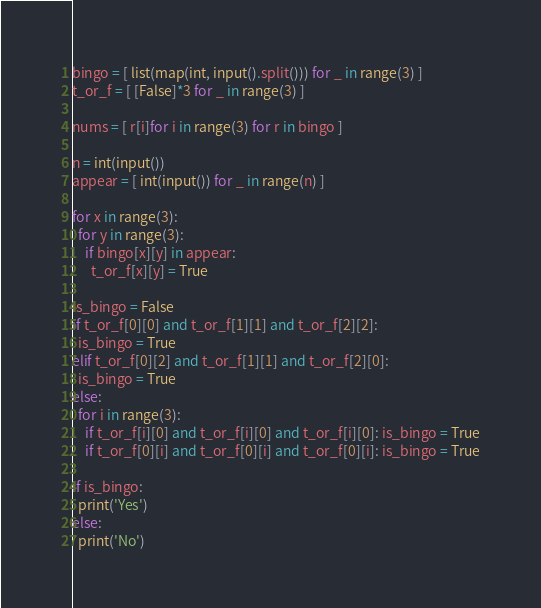<code> <loc_0><loc_0><loc_500><loc_500><_Python_>bingo = [ list(map(int, input().split())) for _ in range(3) ]
t_or_f = [ [False]*3 for _ in range(3) ]

nums = [ r[i]for i in range(3) for r in bingo ]

n = int(input())
appear = [ int(input()) for _ in range(n) ]

for x in range(3):
  for y in range(3):
    if bingo[x][y] in appear:
      t_or_f[x][y] = True

is_bingo = False
if t_or_f[0][0] and t_or_f[1][1] and t_or_f[2][2]:
  is_bingo = True
elif t_or_f[0][2] and t_or_f[1][1] and t_or_f[2][0]:
  is_bingo = True
else:
  for i in range(3):
    if t_or_f[i][0] and t_or_f[i][0] and t_or_f[i][0]: is_bingo = True
    if t_or_f[0][i] and t_or_f[0][i] and t_or_f[0][i]: is_bingo = True

if is_bingo:
  print('Yes')
else:
  print('No')

</code> 